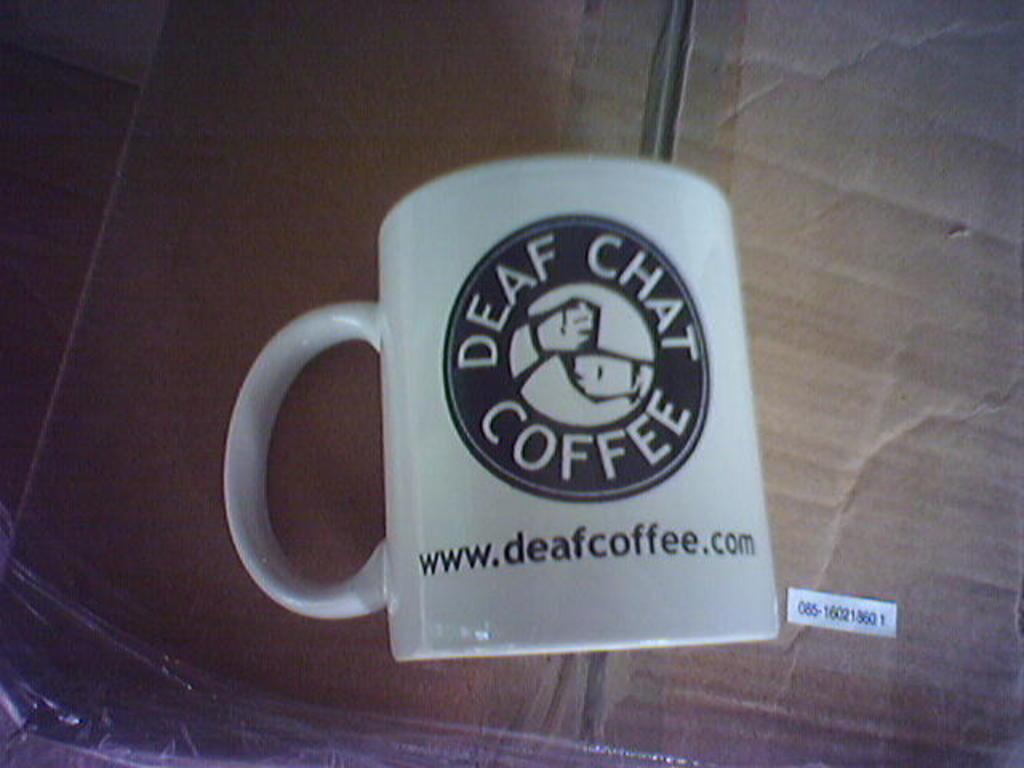What type of coffee is this?
Offer a very short reply. Deaf chat. What is the website for this company?
Ensure brevity in your answer.  Www.deafcoffee.com. 